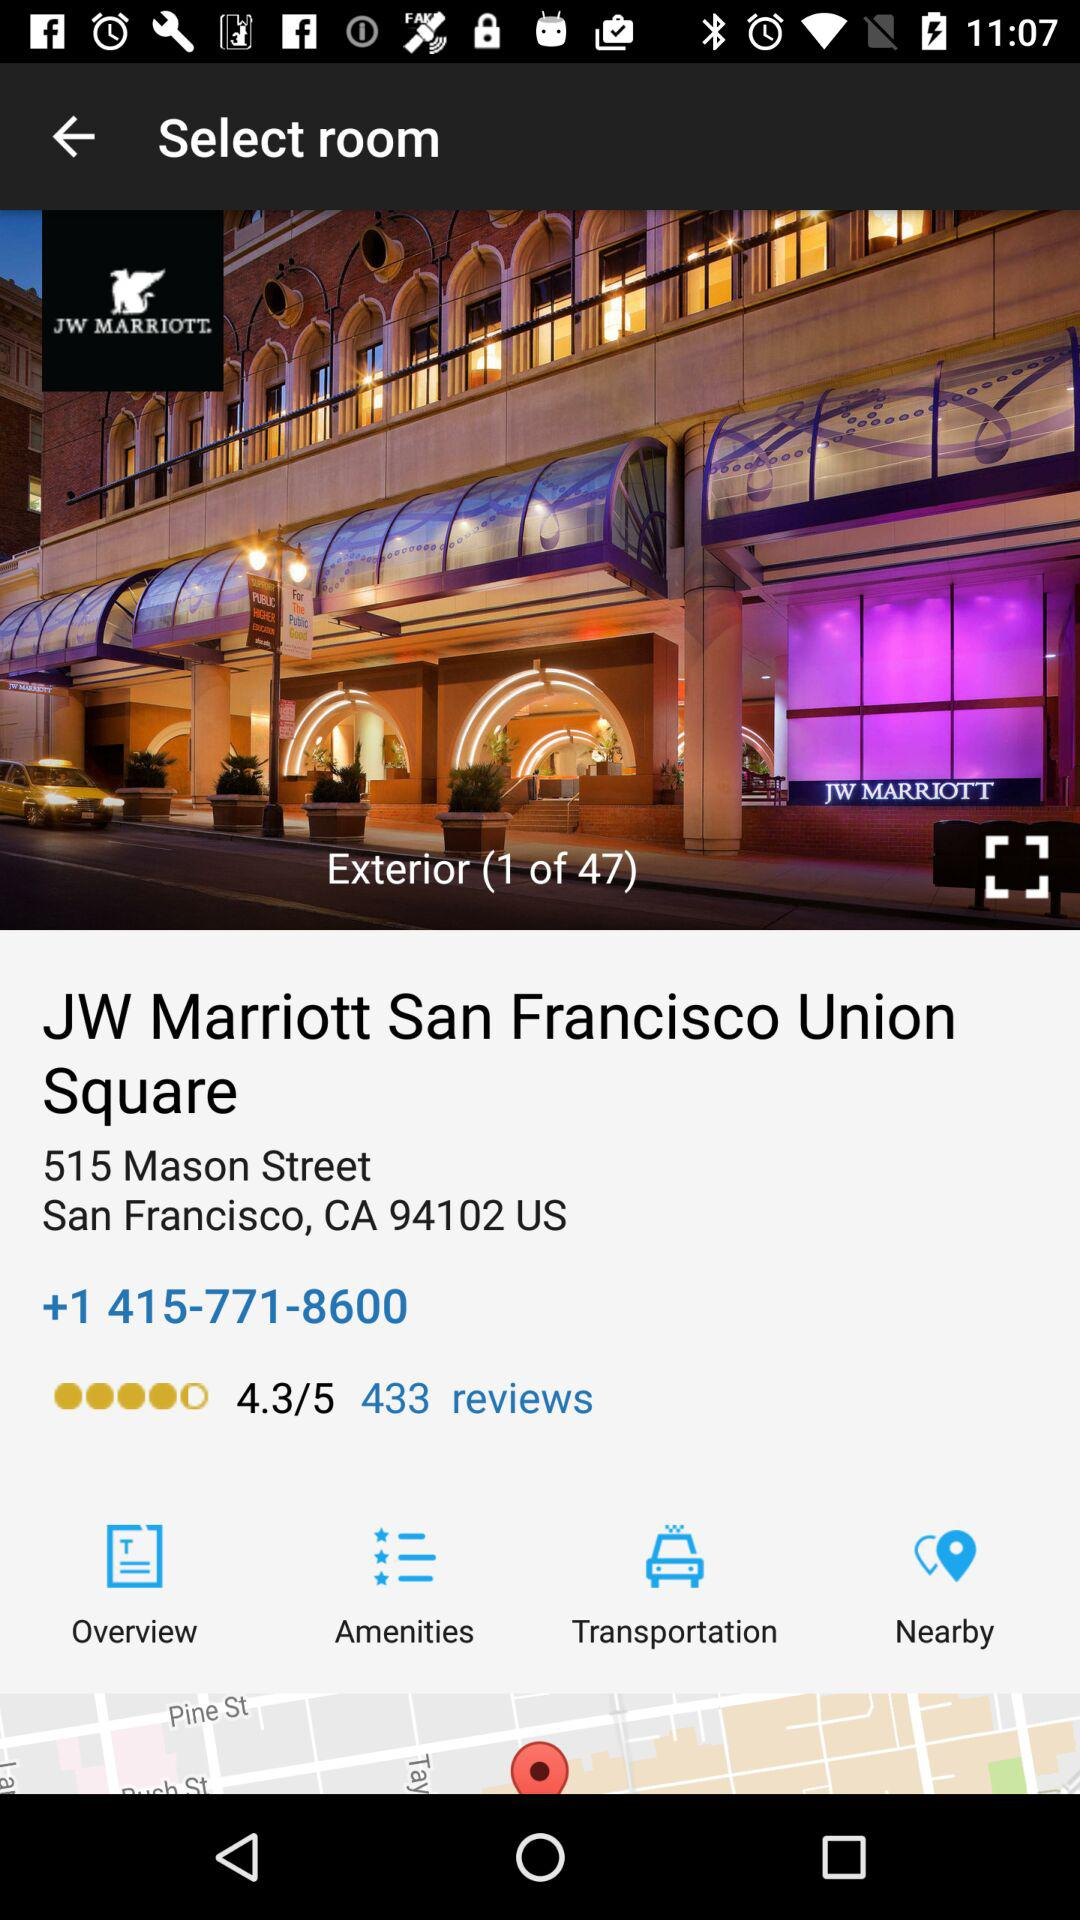What is the phone number for the JW Marriott? The phone number is +1 415-771-8600. 